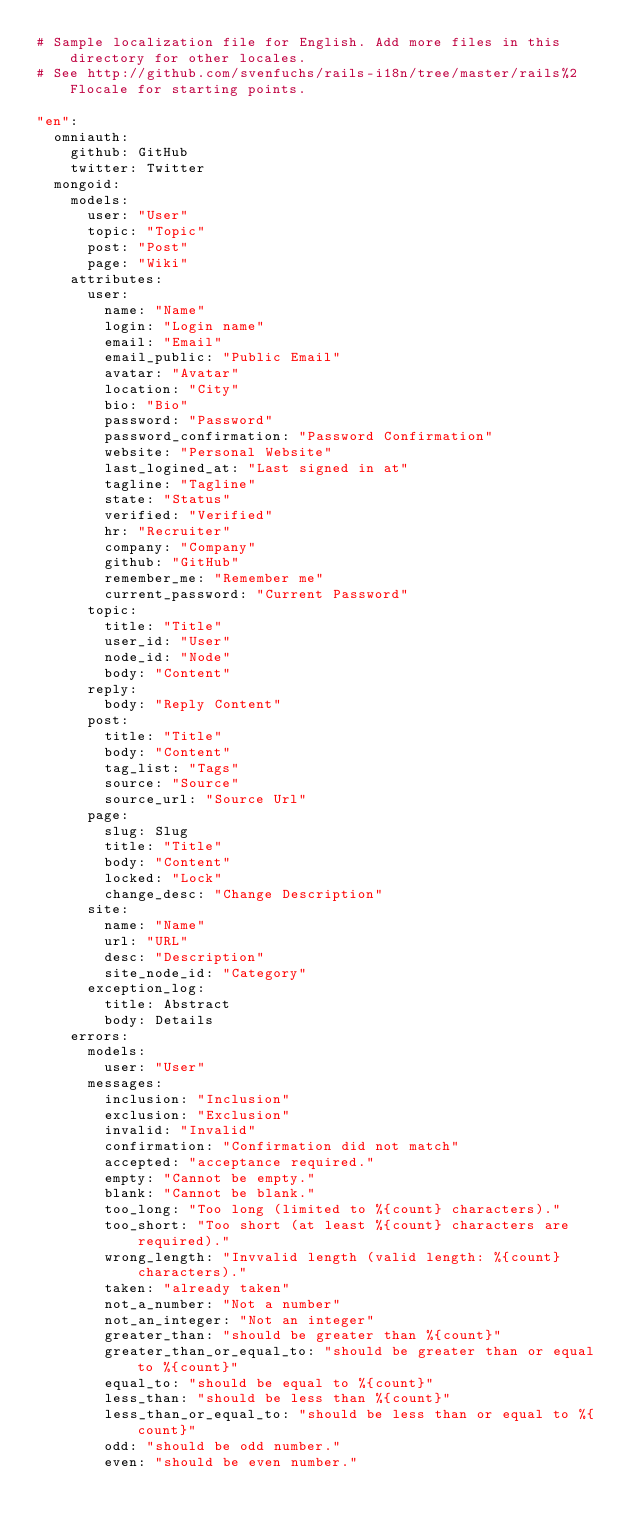<code> <loc_0><loc_0><loc_500><loc_500><_YAML_># Sample localization file for English. Add more files in this directory for other locales.
# See http://github.com/svenfuchs/rails-i18n/tree/master/rails%2Flocale for starting points.

"en":
  omniauth:
    github: GitHub
    twitter: Twitter
  mongoid:
    models:
      user: "User"
      topic: "Topic"
      post: "Post"
      page: "Wiki"
    attributes:
      user:
        name: "Name"
        login: "Login name"
        email: "Email"
        email_public: "Public Email"
        avatar: "Avatar"
        location: "City"
        bio: "Bio"
        password: "Password"
        password_confirmation: "Password Confirmation"
        website: "Personal Website"
        last_logined_at: "Last signed in at"
        tagline: "Tagline"
        state: "Status"
        verified: "Verified"
        hr: "Recruiter"
        company: "Company"
        github: "GitHub"
        remember_me: "Remember me"
        current_password: "Current Password"
      topic:
        title: "Title"
        user_id: "User"
        node_id: "Node"
        body: "Content"
      reply:
        body: "Reply Content"  
      post:
        title: "Title"
        body: "Content"
        tag_list: "Tags"
        source: "Source"
        source_url: "Source Url"        
      page:
        slug: Slug
        title: "Title"
        body: "Content"
        locked: "Lock"
        change_desc: "Change Description"
      site:
        name: "Name"
        url: "URL"
        desc: "Description"
        site_node_id: "Category"
      exception_log:
        title: Abstract
        body: Details
    errors:
      models:
        user: "User"        
      messages:
        inclusion: "Inclusion"
        exclusion: "Exclusion"
        invalid: "Invalid"
        confirmation: "Confirmation did not match"
        accepted: "acceptance required."
        empty: "Cannot be empty."
        blank: "Cannot be blank."
        too_long: "Too long (limited to %{count} characters)."
        too_short: "Too short (at least %{count} characters are required)."
        wrong_length: "Invvalid length (valid length: %{count} characters)."
        taken: "already taken"
        not_a_number: "Not a number"
        not_an_integer: "Not an integer"
        greater_than: "should be greater than %{count}"
        greater_than_or_equal_to: "should be greater than or equal to %{count}"
        equal_to: "should be equal to %{count}"
        less_than: "should be less than %{count}"
        less_than_or_equal_to: "should be less than or equal to %{count}"
        odd: "should be odd number."
        even: "should be even number."
</code> 